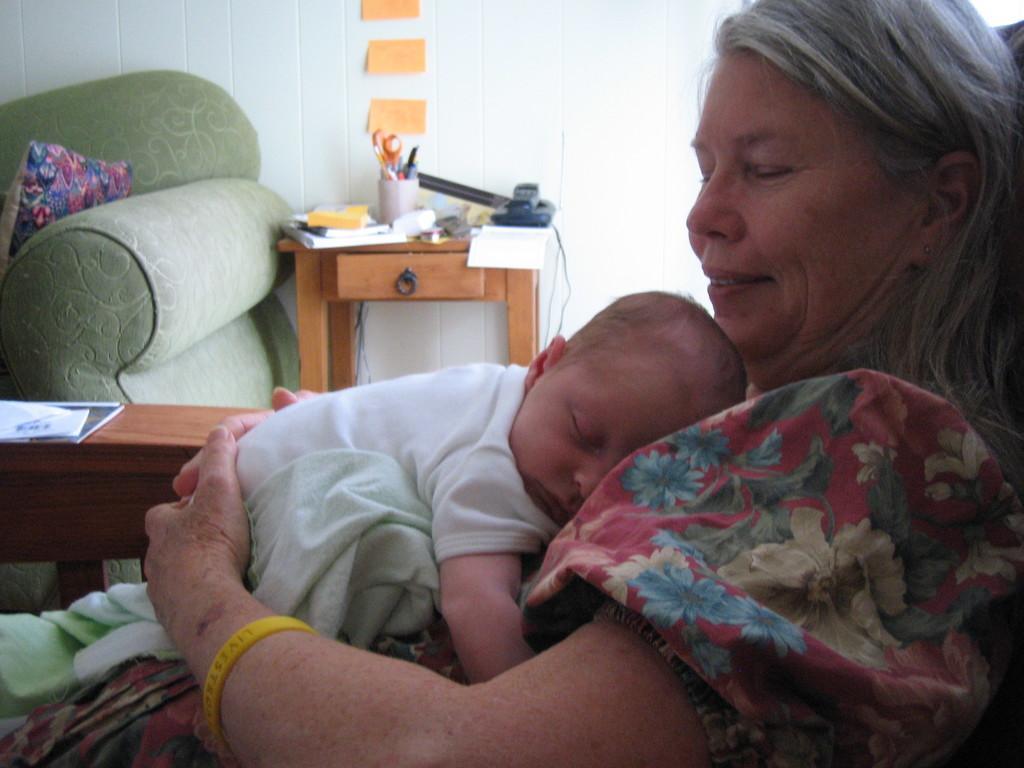In one or two sentences, can you explain what this image depicts? In this image I see a woman who is sitting and there is a baby on her. In the background I see the wall, a table on which there are few things and a couch. 